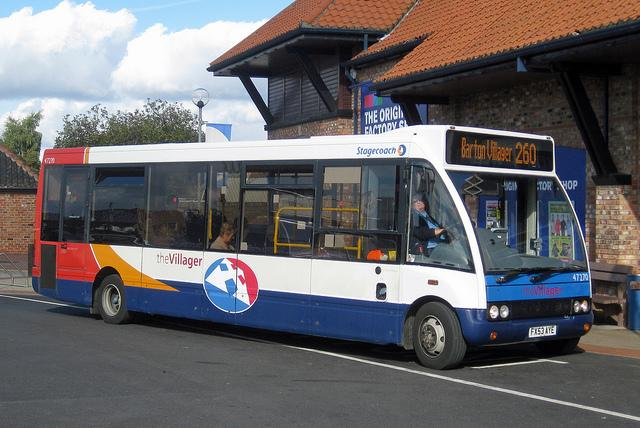Where does this bus stop here? Please explain your reasoning. outlet mall. The bus is by an outlet. 